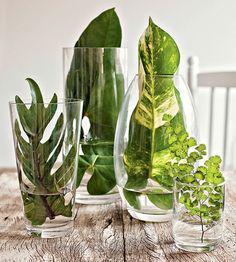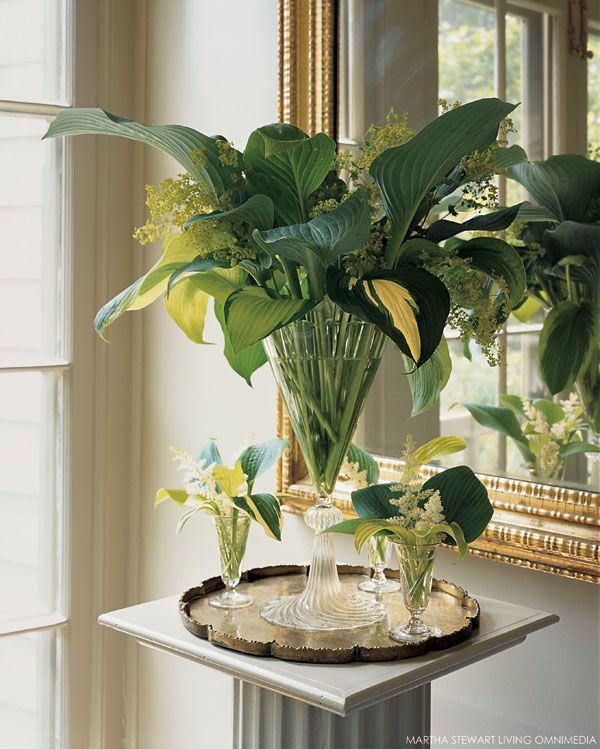The first image is the image on the left, the second image is the image on the right. Assess this claim about the two images: "An image shows several clear glasses on a wood surface, and at least one contains a variegated green-and-whitish leaf.". Correct or not? Answer yes or no. Yes. 